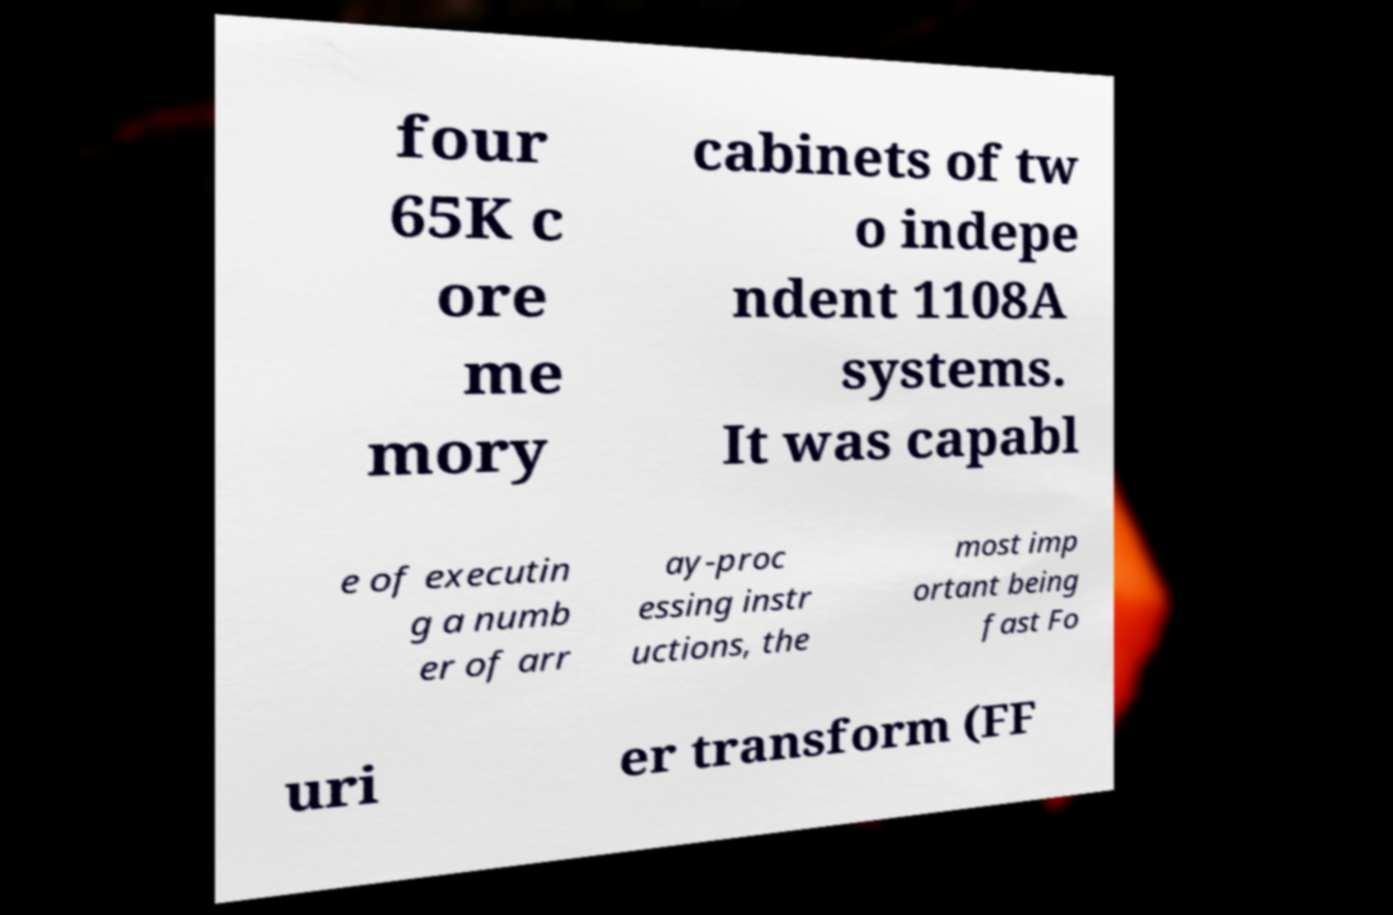Can you accurately transcribe the text from the provided image for me? four 65K c ore me mory cabinets of tw o indepe ndent 1108A systems. It was capabl e of executin g a numb er of arr ay-proc essing instr uctions, the most imp ortant being fast Fo uri er transform (FF 